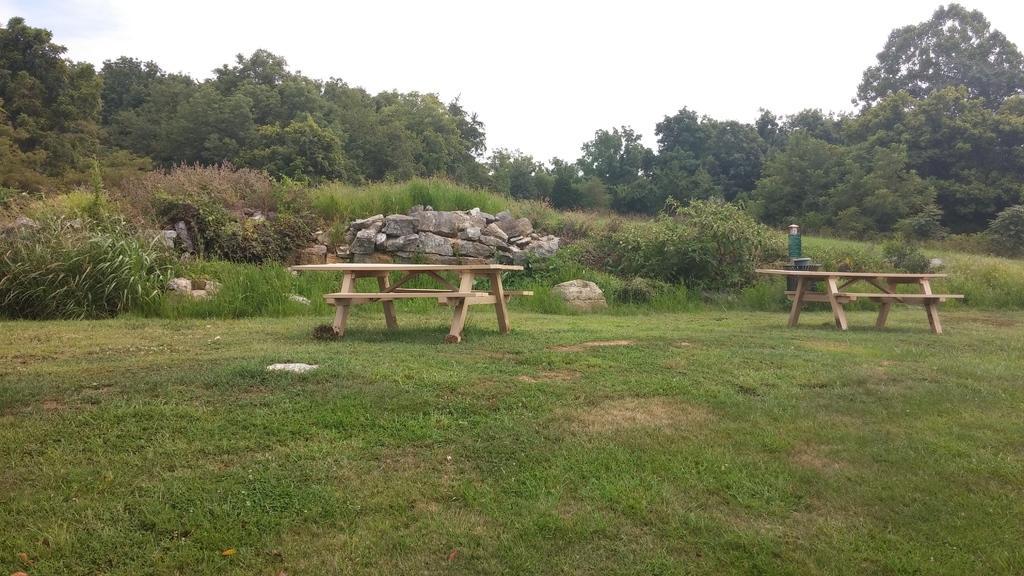Please provide a concise description of this image. In this image we can see benches on the grass. In the background we can see stones, trees, plants, grass and sky. At the bottom of the image there is grass. 